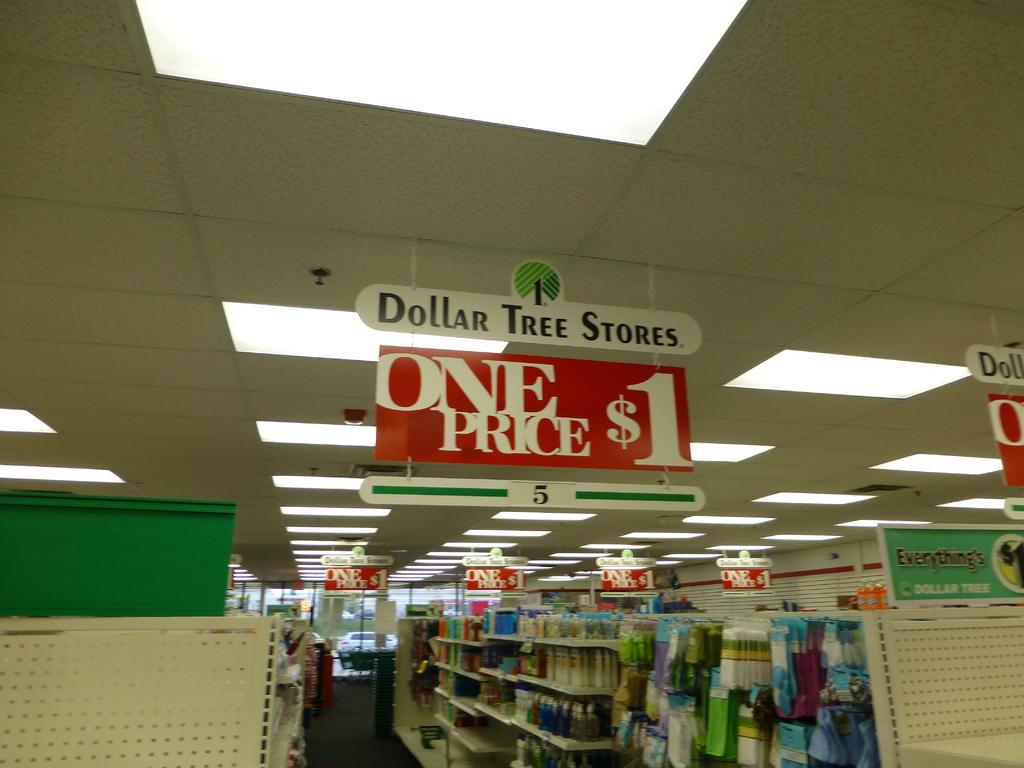<image>
Provide a brief description of the given image. Store aisle with a sign that says Dollar Tree Stores. 